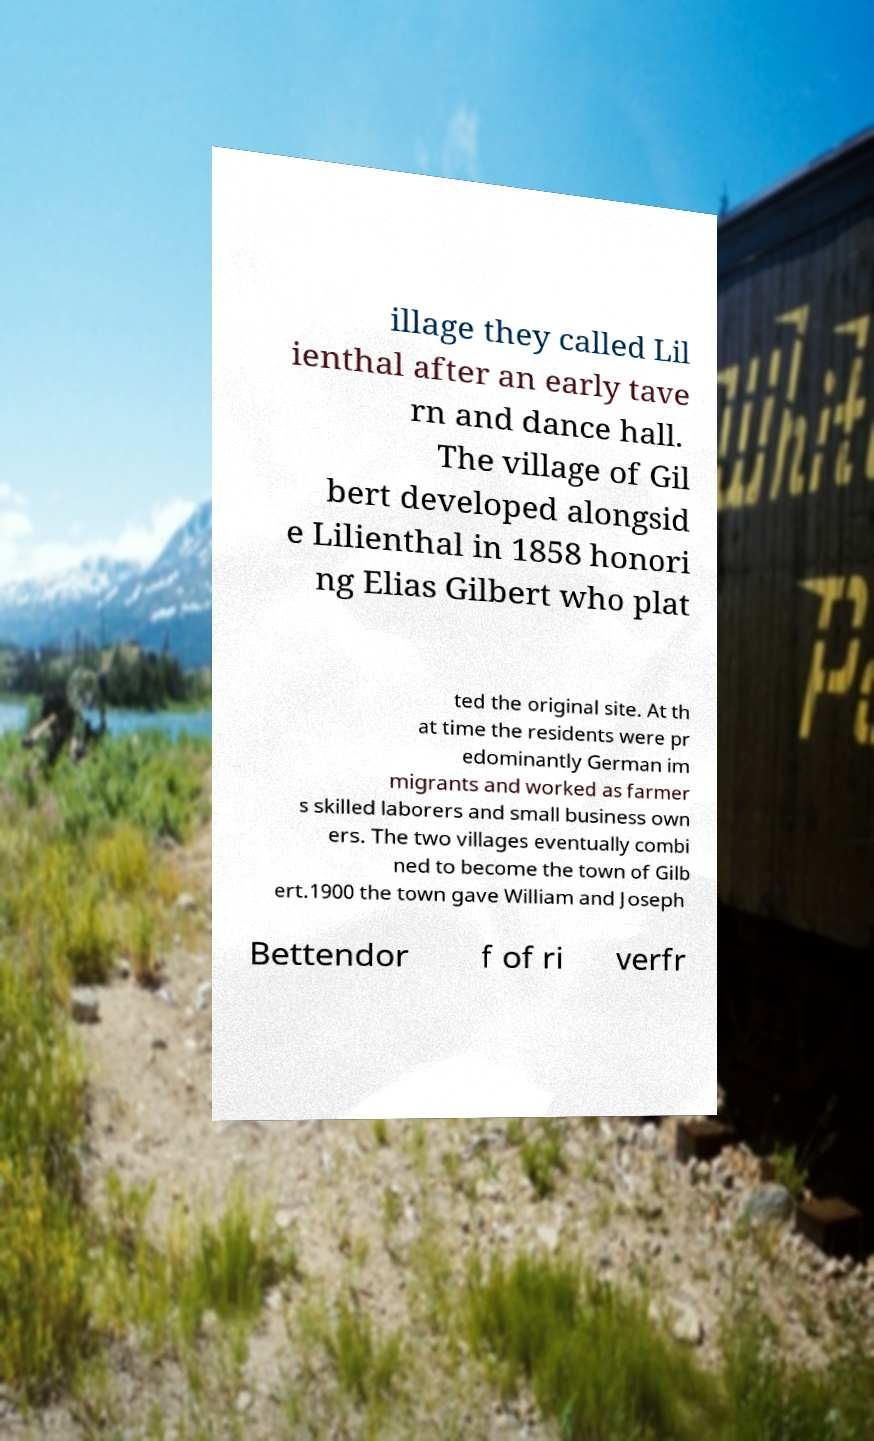I need the written content from this picture converted into text. Can you do that? illage they called Lil ienthal after an early tave rn and dance hall. The village of Gil bert developed alongsid e Lilienthal in 1858 honori ng Elias Gilbert who plat ted the original site. At th at time the residents were pr edominantly German im migrants and worked as farmer s skilled laborers and small business own ers. The two villages eventually combi ned to become the town of Gilb ert.1900 the town gave William and Joseph Bettendor f of ri verfr 